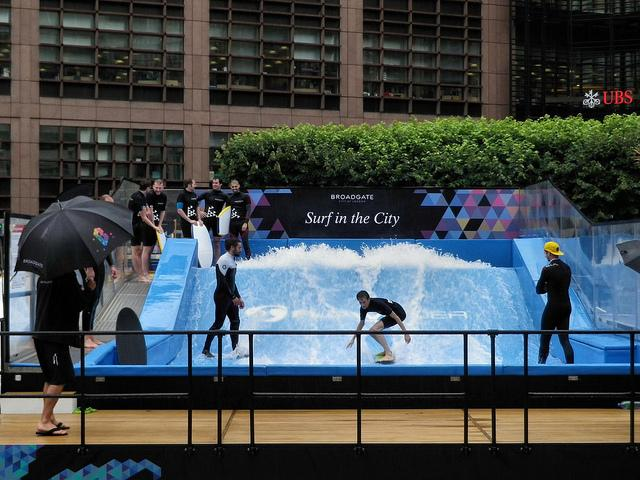What sort of building is seen behind this amusement? Please explain your reasoning. financial. A bank logo is on the side of a bank. 